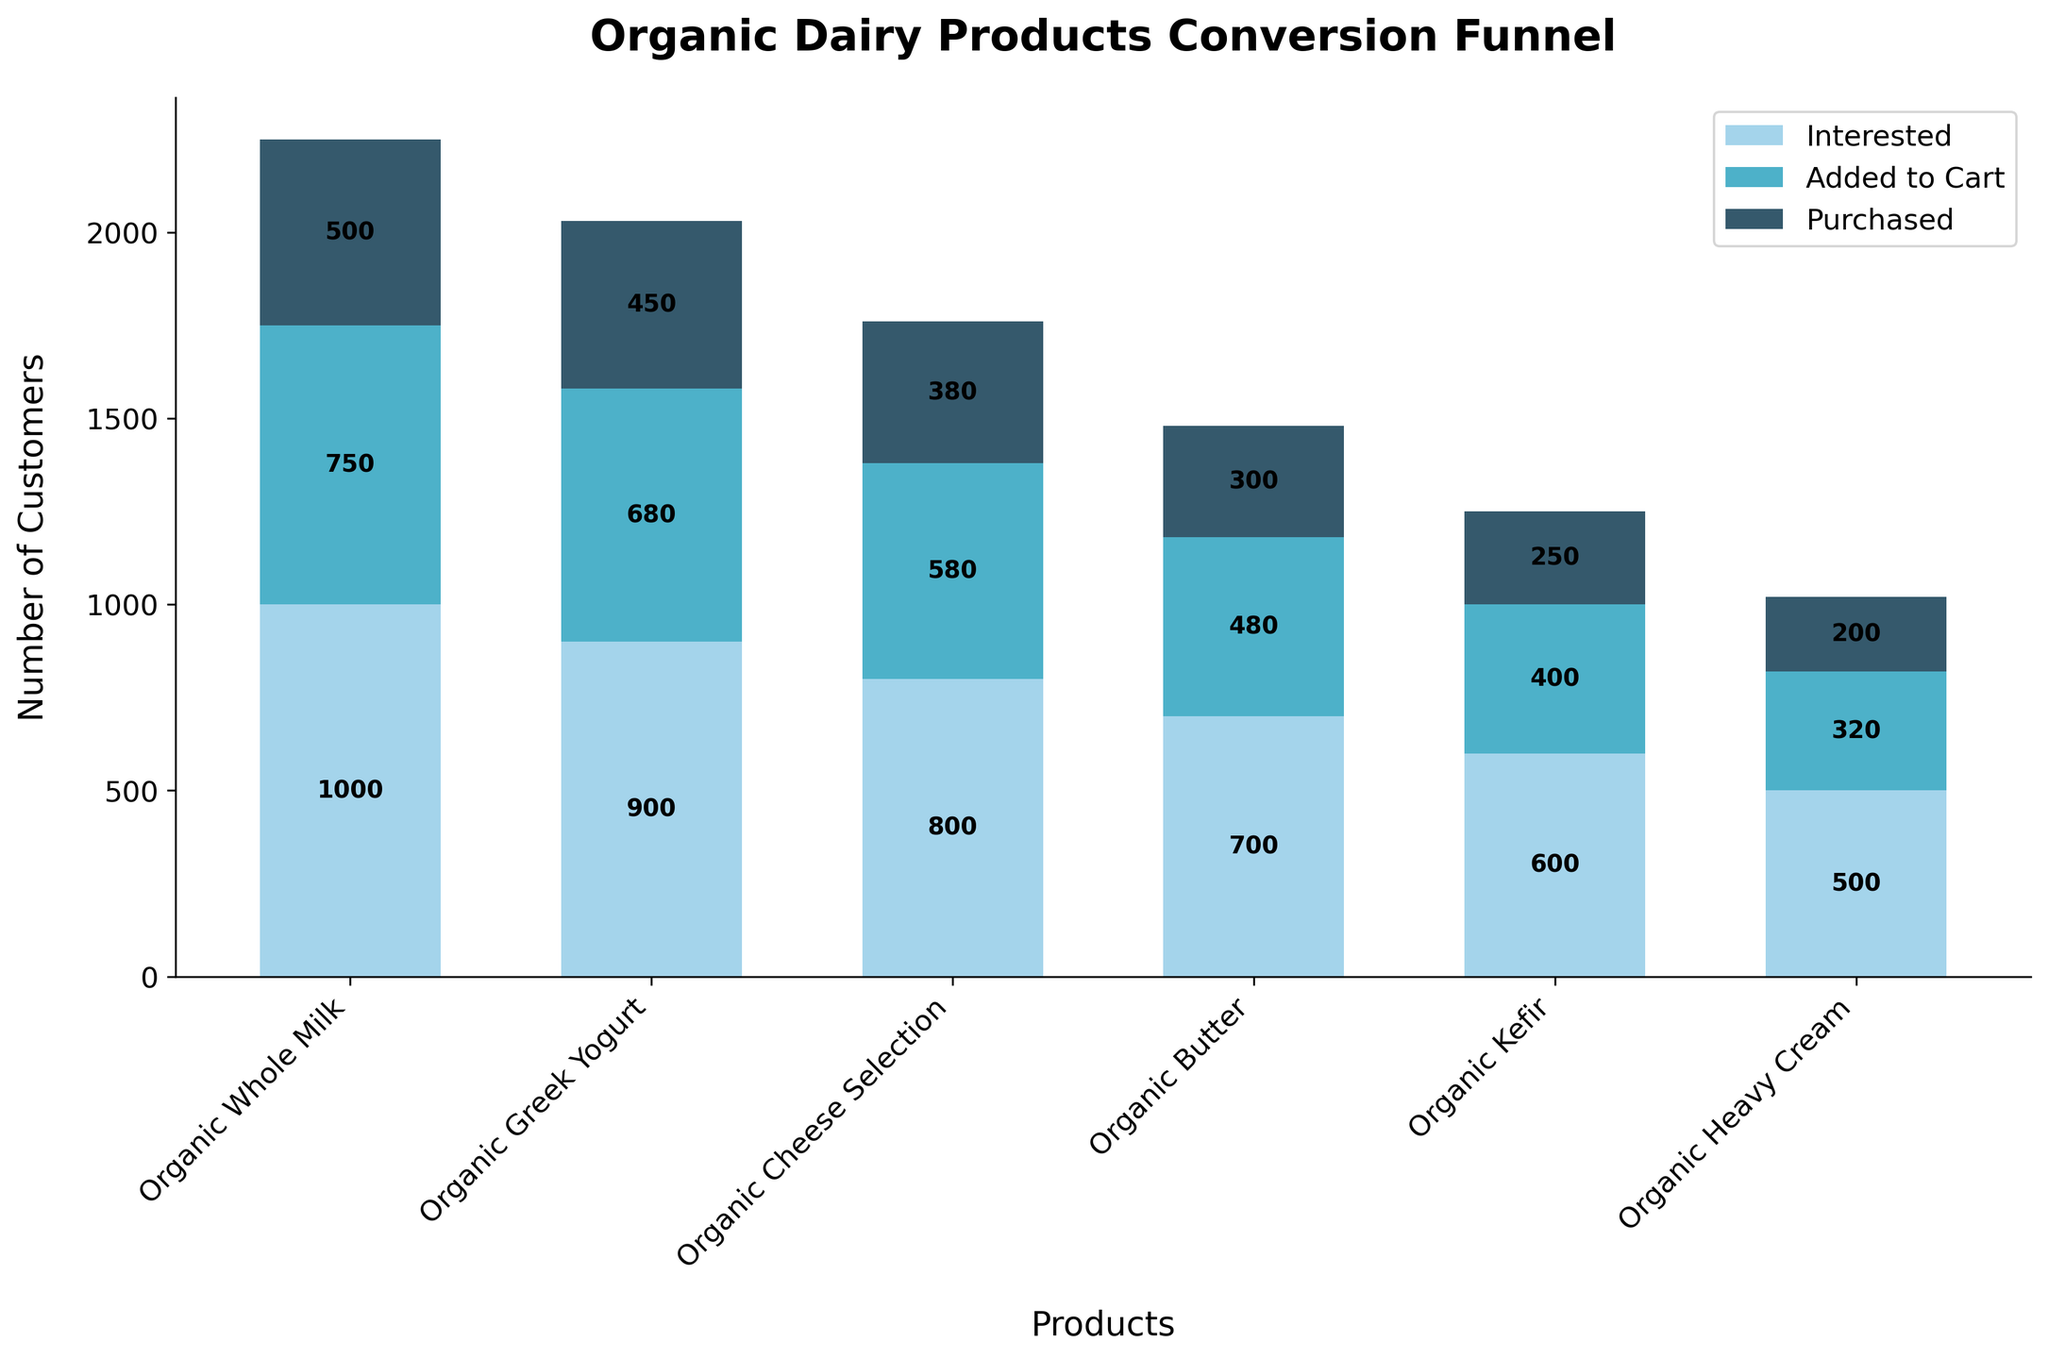What is the title of the figure? The title is found at the top of the figure, providing a brief description of what the chart is demonstrating.
Answer: Organic Dairy Products Conversion Funnel How many products are displayed in the funnel chart? The products are listed along the x-axis of the chart. By counting them, we can determine the number of products.
Answer: 6 Which product had the highest number of interested customers? By comparing the heights of the bars for the 'Interested' stage for each product, we can determine which is the highest.
Answer: Organic Whole Milk What percentage of interested customers added Organic Greek Yogurt to their cart? Calculate the percentage by dividing the number of 'Added to Cart' customers by the number of 'Interested' customers for Organic Greek Yogurt, then multiply by 100: (680/900) * 100.
Answer: 75.56% What is the total number of customers who purchased any product? Sum the values for the 'Purchased' stage for all products: 500 + 450 + 380 + 300 + 250 + 200.
Answer: 2080 Which product had the smallest drop in customer numbers from 'Added to Cart' to 'Purchased'? Calculate the difference for each product between 'Added to Cart' and 'Purchased', and identify the smallest value.
Answer: Organic Heavy Cream How many stages are there in the funnel for each product? By looking at the legend or the visual stages in the bar chart, we can count the number of stages.
Answer: 3 Which product had the highest conversion rate from 'Interested' to 'Purchased'? Calculate the conversion rate by dividing the 'Purchased' numbers by the 'Interested' numbers for each product and compare the values: Organic Whole Milk = 50%, Greek Yogurt = 50%, Cheese Selection = 47.5%, Butter = 42.86%, Kefir = 41.67%, Heavy Cream = 40%.
Answer: Organic Whole Milk and Organic Greek Yogurt Between Organic Butter and Organic Kefir, which had more customers adding the product to their cart? Compare the 'Added to Cart' bar heights for Organic Butter and Organic Kefir.
Answer: Organic Butter What is the average number of customers who purchased Organic Whole Milk, Organic Greek Yogurt, and Organic Cheese Selection? Sum the 'Purchased' numbers for these three products and divide by 3: (500 + 450 + 380) / 3.
Answer: 443.33 